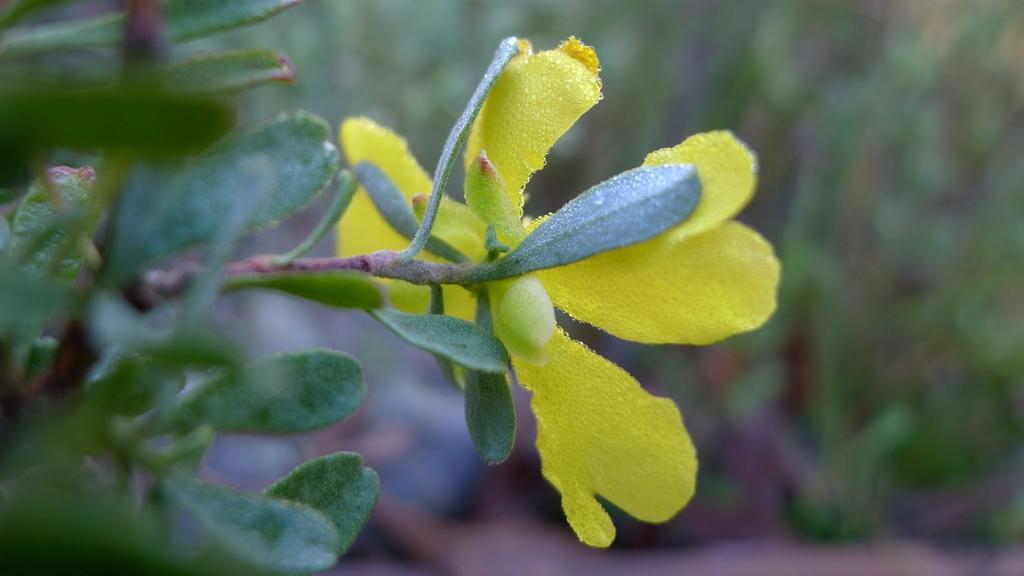What type of plant is visible in the image? There is a plant in the image. What specific part of the plant is featured in the image? There is a flower in the image. What can be seen in the background of the image? There are plants in the background of the image. How many bridges can be seen crossing the river in the image? There is no river or bridge present in the image; it features a plant with a flower and plants in the background. What type of push is required to move the plant in the image? The plant in the image is stationary and does not require any pushing to move. 